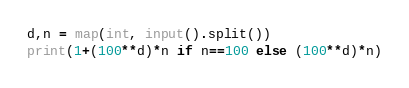Convert code to text. <code><loc_0><loc_0><loc_500><loc_500><_Python_>d,n = map(int, input().split())
print(1+(100**d)*n if n==100 else (100**d)*n)</code> 